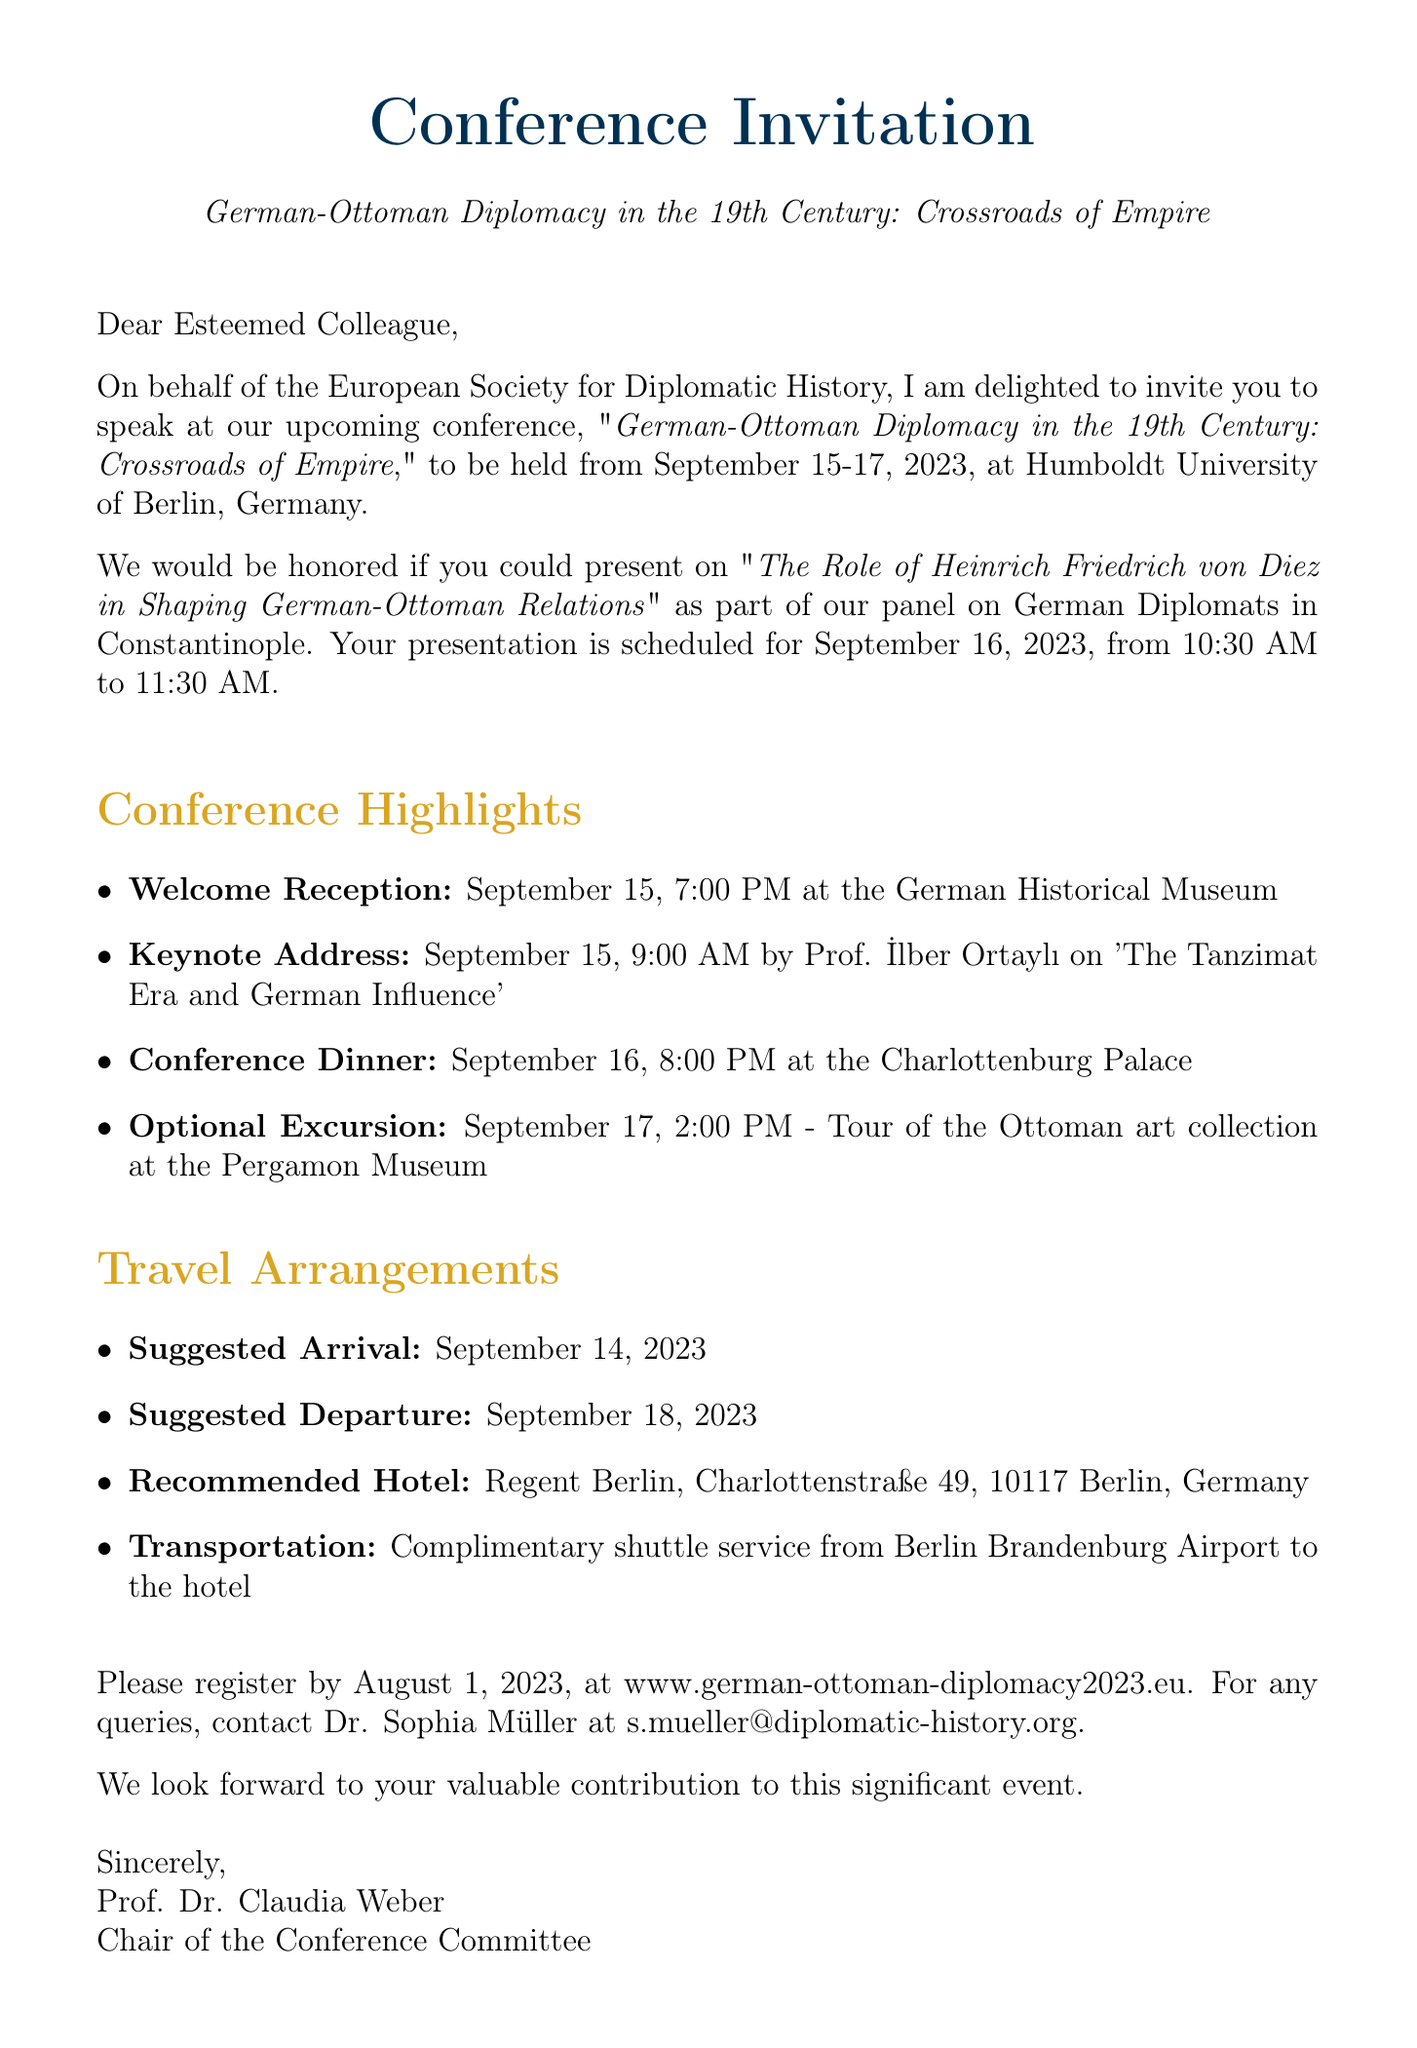What are the conference dates? The dates of the conference are September 15-17, 2023.
Answer: September 15-17, 2023 Who is the keynote speaker? The keynote address is by Prof. İlber Ortaylı.
Answer: Prof. İlber Ortaylı What is the title of your proposed presentation? The proposed presentation is titled "The Role of Heinrich Friedrich von Diez in Shaping German-Ottoman Relations."
Answer: The Role of Heinrich Friedrich von Diez in Shaping German-Ottoman Relations What is the location of the welcome reception? The welcome reception is located at the German Historical Museum.
Answer: German Historical Museum When is the registration deadline? The registration deadline is August 1, 2023.
Answer: August 1, 2023 What is the recommended hotel for attendees? The recommended hotel for attendees is Regent Berlin.
Answer: Regent Berlin What time will the conference dinner take place? The conference dinner is scheduled for 8:00 PM on September 16, 2023.
Answer: 8:00 PM What transportation is provided from the airport? There is a complimentary shuttle service from Berlin Brandenburg Airport to the hotel.
Answer: Complimentary shuttle service What is the date and time of your presentation? The presentation is scheduled for September 16, 2023, from 10:30 AM to 11:30 AM.
Answer: September 16, 2023, 10:30 AM - 11:30 AM 